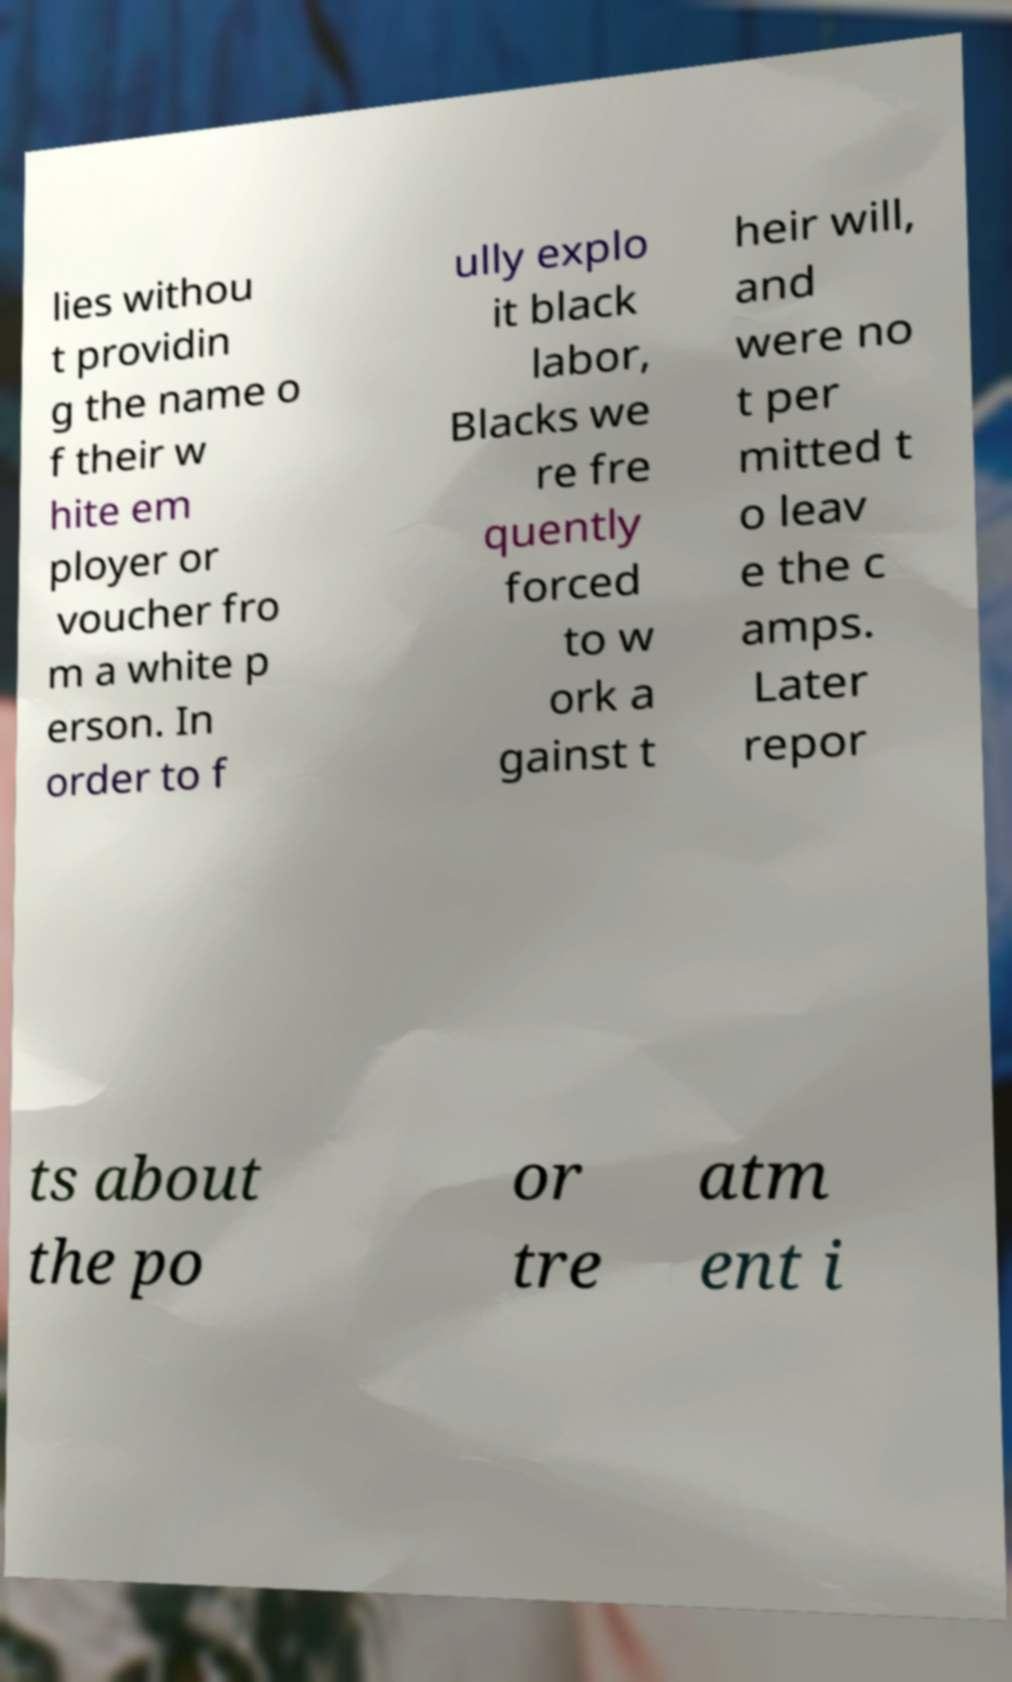Please identify and transcribe the text found in this image. lies withou t providin g the name o f their w hite em ployer or voucher fro m a white p erson. In order to f ully explo it black labor, Blacks we re fre quently forced to w ork a gainst t heir will, and were no t per mitted t o leav e the c amps. Later repor ts about the po or tre atm ent i 